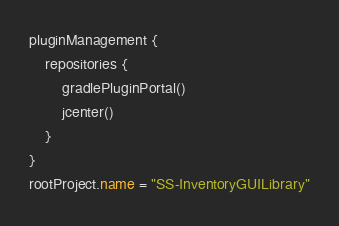Convert code to text. <code><loc_0><loc_0><loc_500><loc_500><_Kotlin_>pluginManagement {
    repositories {
        gradlePluginPortal()
        jcenter()
    }
}
rootProject.name = "SS-InventoryGUILibrary"</code> 